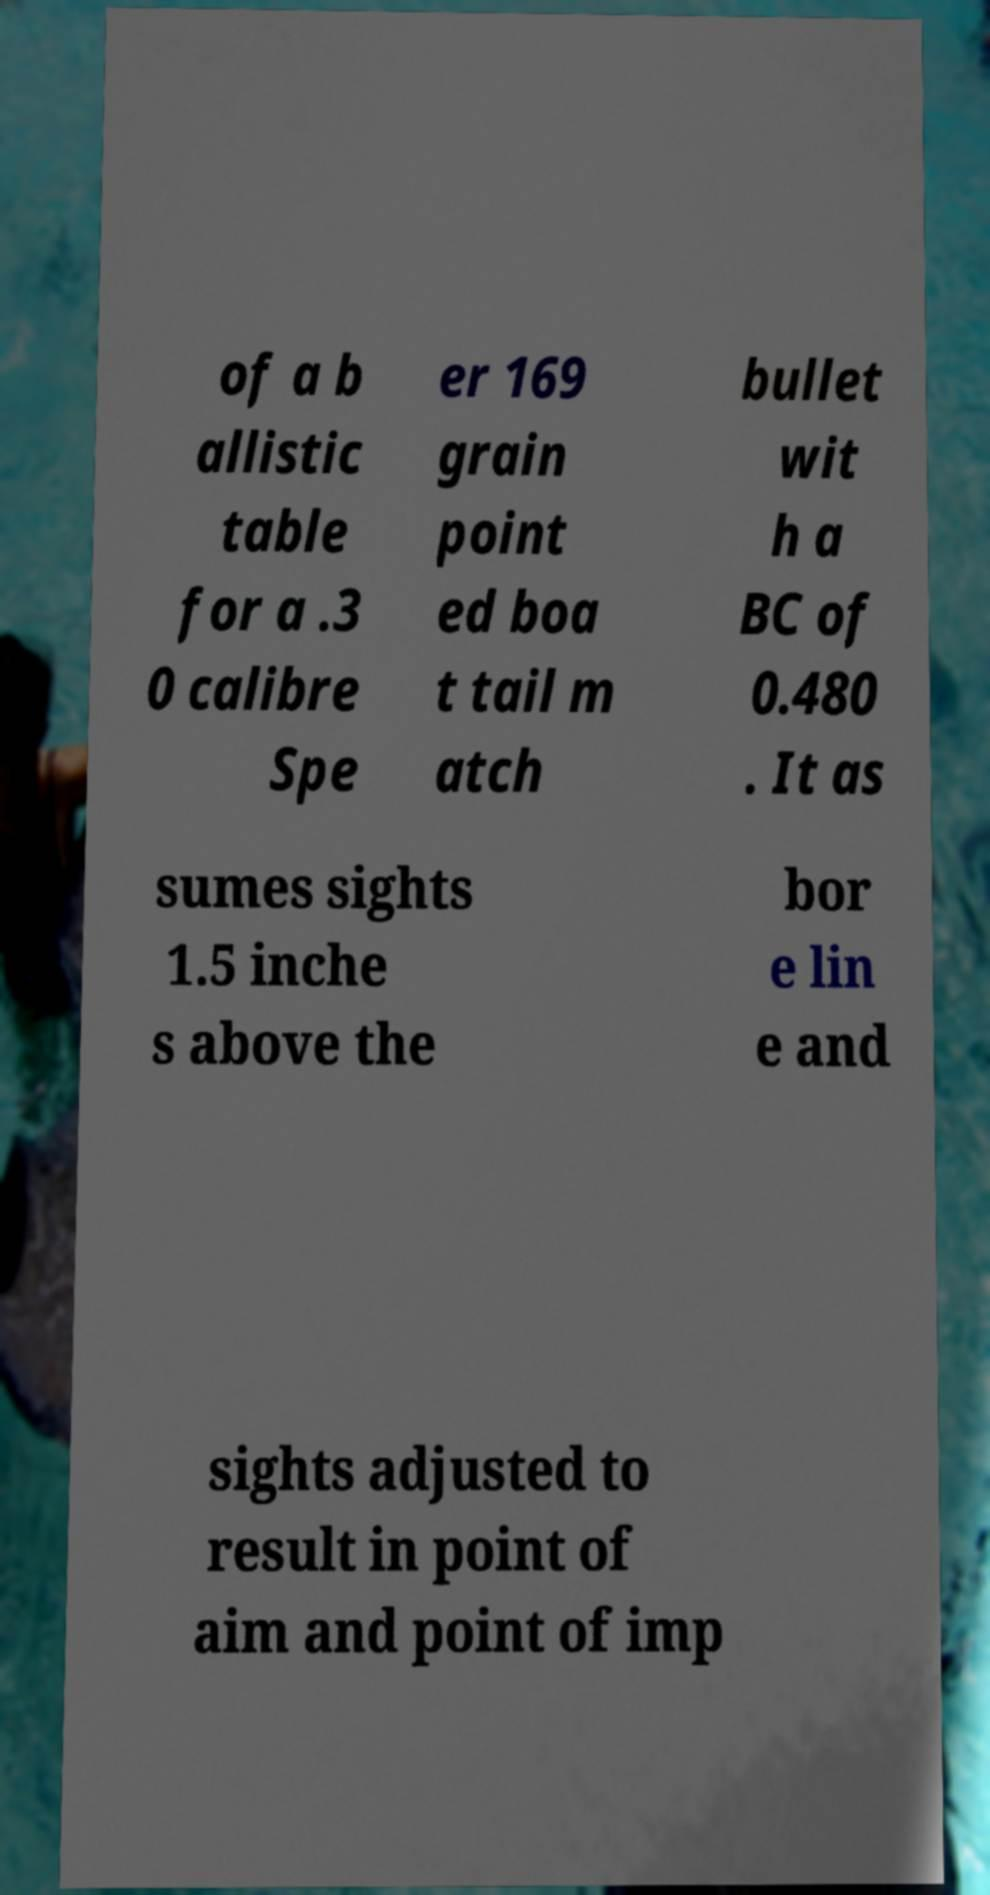Can you read and provide the text displayed in the image?This photo seems to have some interesting text. Can you extract and type it out for me? of a b allistic table for a .3 0 calibre Spe er 169 grain point ed boa t tail m atch bullet wit h a BC of 0.480 . It as sumes sights 1.5 inche s above the bor e lin e and sights adjusted to result in point of aim and point of imp 